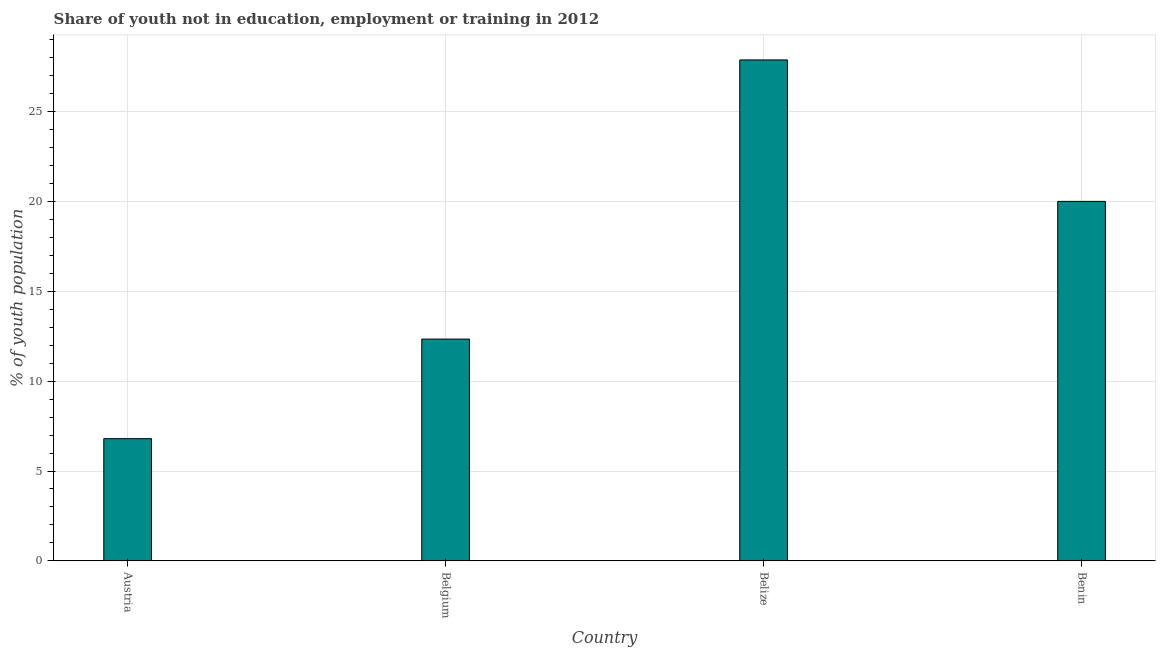Does the graph contain any zero values?
Ensure brevity in your answer.  No. Does the graph contain grids?
Provide a succinct answer. Yes. What is the title of the graph?
Give a very brief answer. Share of youth not in education, employment or training in 2012. What is the label or title of the Y-axis?
Ensure brevity in your answer.  % of youth population. What is the unemployed youth population in Belgium?
Offer a very short reply. 12.34. Across all countries, what is the maximum unemployed youth population?
Provide a short and direct response. 27.87. Across all countries, what is the minimum unemployed youth population?
Provide a short and direct response. 6.8. In which country was the unemployed youth population maximum?
Offer a terse response. Belize. What is the sum of the unemployed youth population?
Your response must be concise. 67.01. What is the difference between the unemployed youth population in Belgium and Belize?
Offer a terse response. -15.53. What is the average unemployed youth population per country?
Your response must be concise. 16.75. What is the median unemployed youth population?
Provide a short and direct response. 16.17. What is the ratio of the unemployed youth population in Austria to that in Belgium?
Your response must be concise. 0.55. Is the unemployed youth population in Austria less than that in Belgium?
Provide a short and direct response. Yes. Is the difference between the unemployed youth population in Austria and Belize greater than the difference between any two countries?
Provide a short and direct response. Yes. What is the difference between the highest and the second highest unemployed youth population?
Your answer should be very brief. 7.87. What is the difference between the highest and the lowest unemployed youth population?
Keep it short and to the point. 21.07. How many countries are there in the graph?
Your response must be concise. 4. What is the difference between two consecutive major ticks on the Y-axis?
Give a very brief answer. 5. What is the % of youth population of Austria?
Ensure brevity in your answer.  6.8. What is the % of youth population of Belgium?
Your answer should be very brief. 12.34. What is the % of youth population in Belize?
Provide a short and direct response. 27.87. What is the difference between the % of youth population in Austria and Belgium?
Make the answer very short. -5.54. What is the difference between the % of youth population in Austria and Belize?
Your response must be concise. -21.07. What is the difference between the % of youth population in Belgium and Belize?
Ensure brevity in your answer.  -15.53. What is the difference between the % of youth population in Belgium and Benin?
Your answer should be compact. -7.66. What is the difference between the % of youth population in Belize and Benin?
Give a very brief answer. 7.87. What is the ratio of the % of youth population in Austria to that in Belgium?
Offer a very short reply. 0.55. What is the ratio of the % of youth population in Austria to that in Belize?
Make the answer very short. 0.24. What is the ratio of the % of youth population in Austria to that in Benin?
Give a very brief answer. 0.34. What is the ratio of the % of youth population in Belgium to that in Belize?
Offer a terse response. 0.44. What is the ratio of the % of youth population in Belgium to that in Benin?
Your answer should be very brief. 0.62. What is the ratio of the % of youth population in Belize to that in Benin?
Your answer should be very brief. 1.39. 